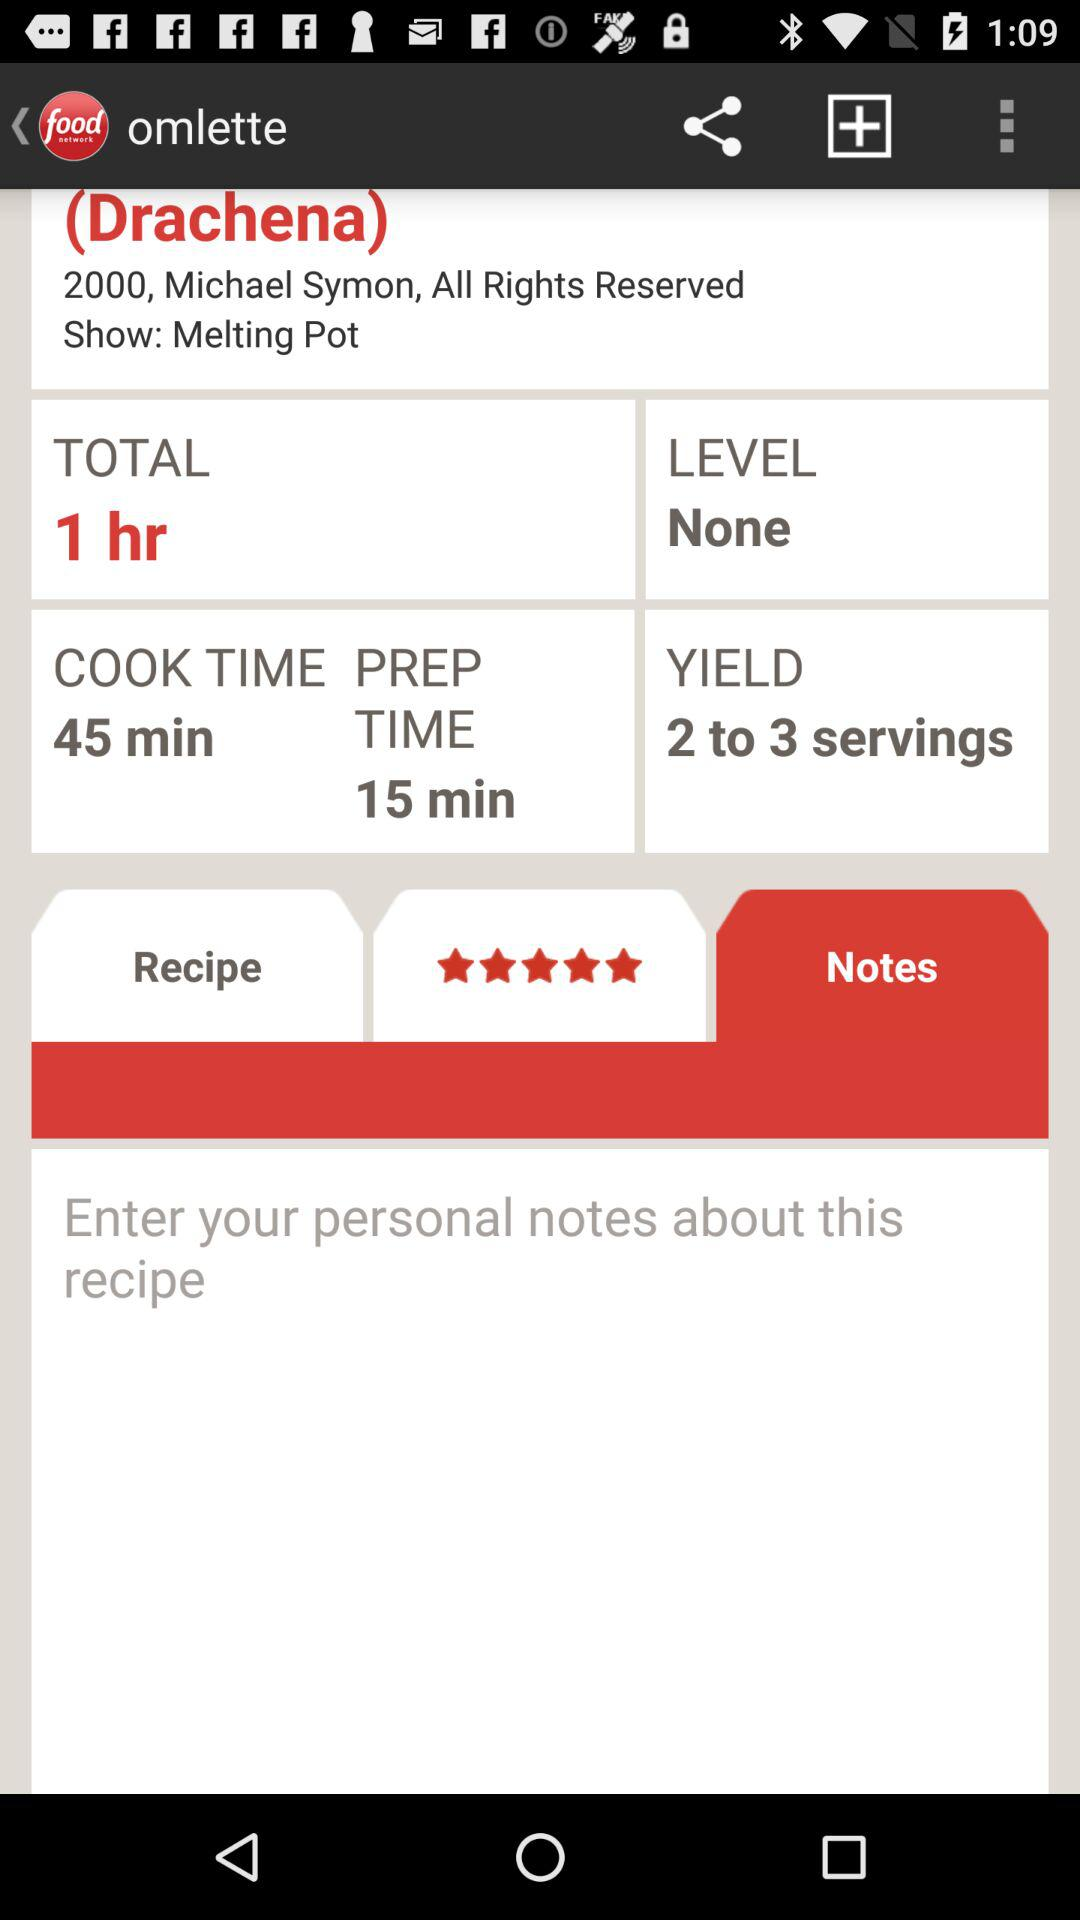What is the preparation time duration? The preparation time duration is 15 minutes. 